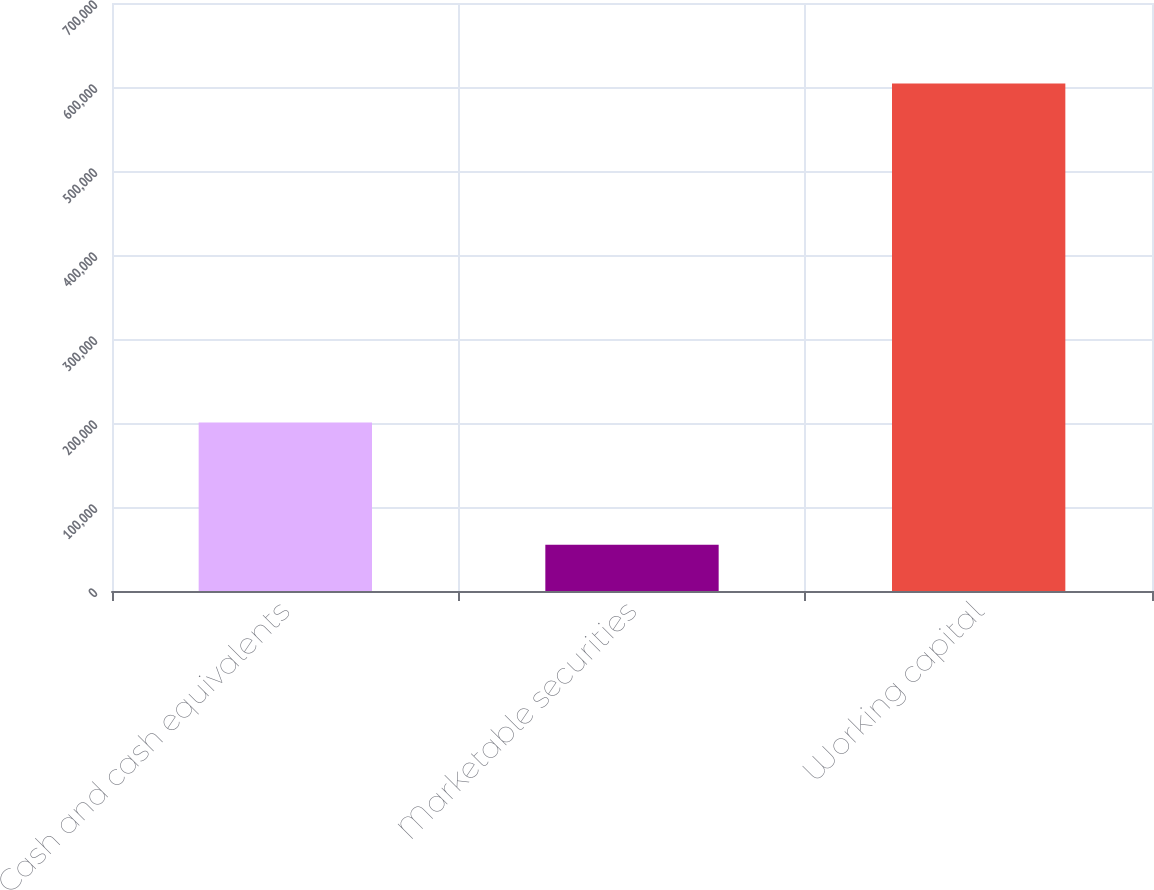Convert chart to OTSL. <chart><loc_0><loc_0><loc_500><loc_500><bar_chart><fcel>Cash and cash equivalents<fcel>Marketable securities<fcel>Working capital<nl><fcel>200651<fcel>55185<fcel>604199<nl></chart> 